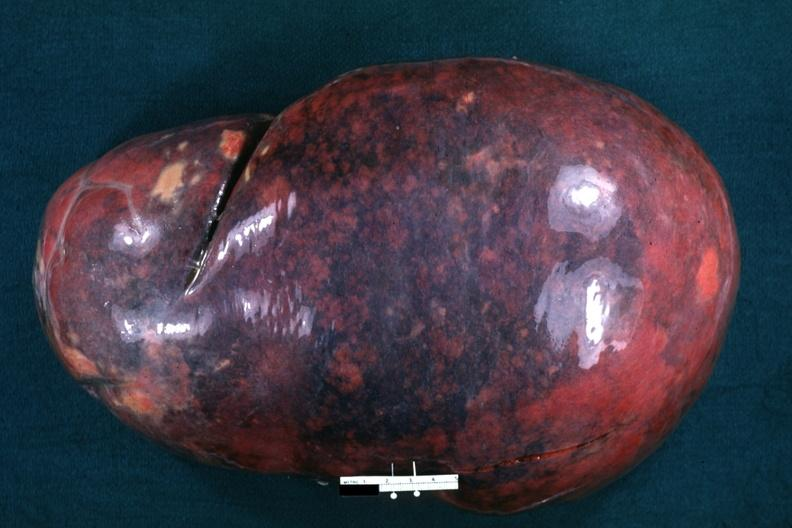s hematologic present?
Answer the question using a single word or phrase. Yes 